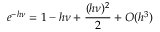<formula> <loc_0><loc_0><loc_500><loc_500>e ^ { - h \nu } = 1 - h \nu + \frac { ( h \nu ) ^ { 2 } } { 2 } + O ( h ^ { 3 } )</formula> 